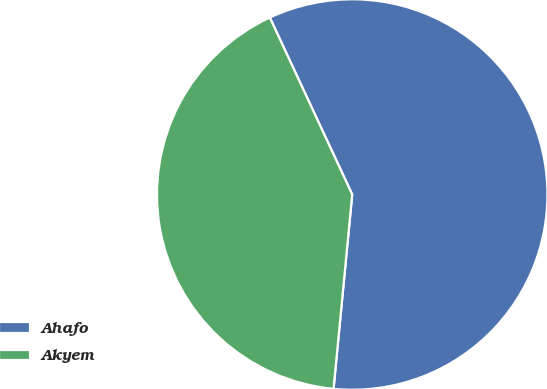Convert chart to OTSL. <chart><loc_0><loc_0><loc_500><loc_500><pie_chart><fcel>Ahafo<fcel>Akyem<nl><fcel>58.46%<fcel>41.54%<nl></chart> 